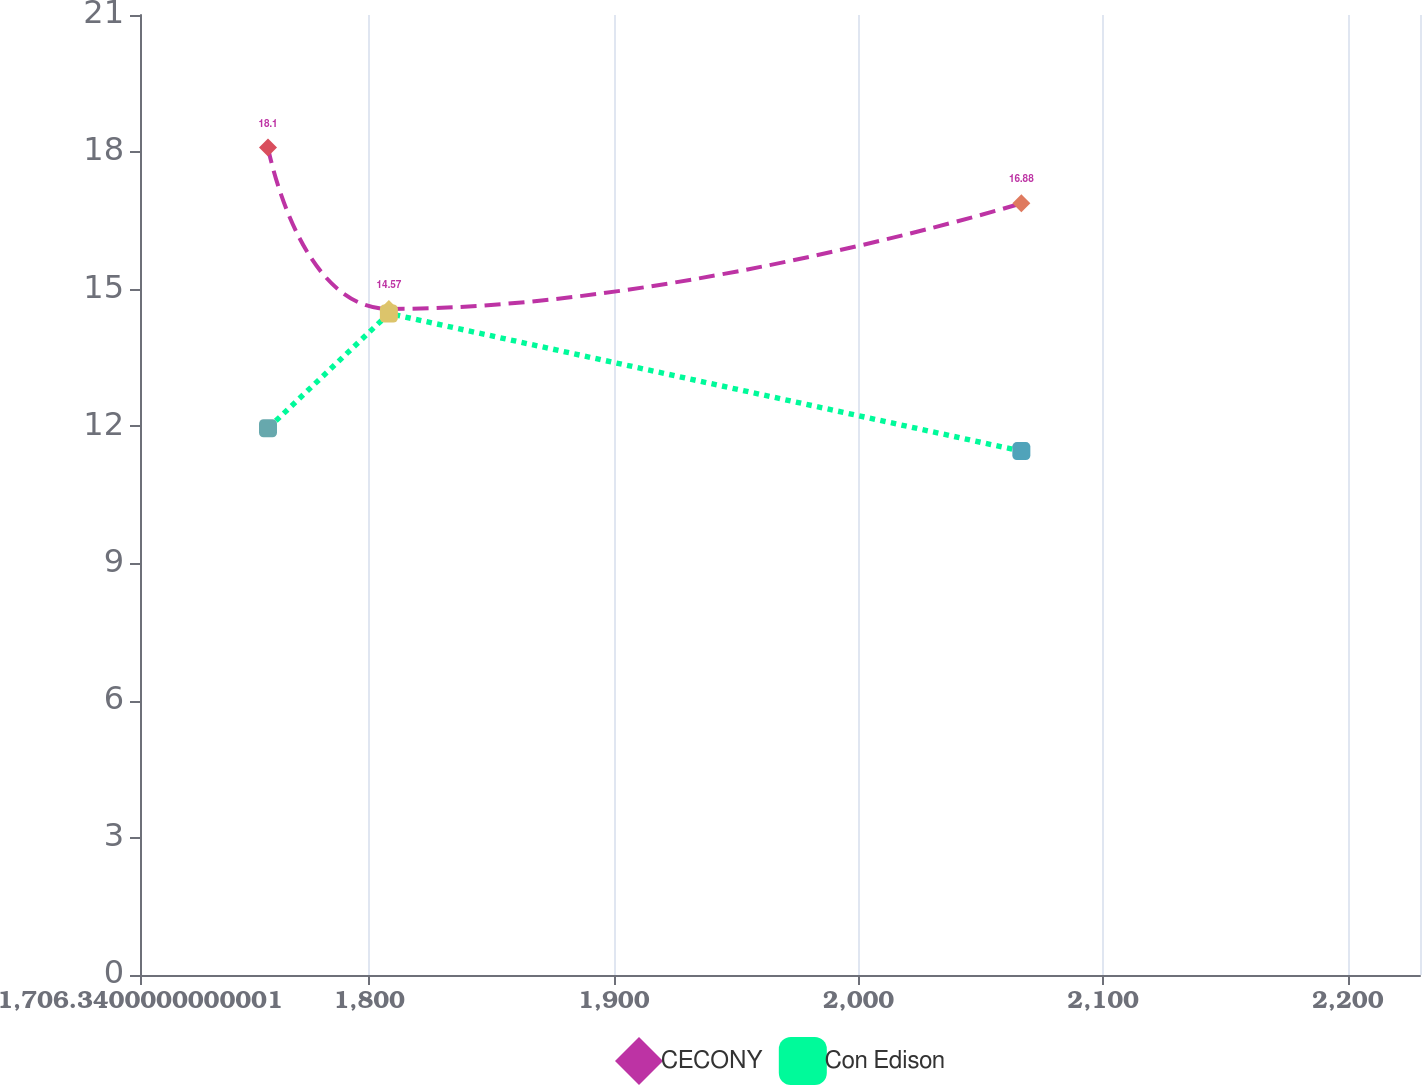Convert chart. <chart><loc_0><loc_0><loc_500><loc_500><line_chart><ecel><fcel>CECONY<fcel>Con Edison<nl><fcel>1758.66<fcel>18.1<fcel>11.96<nl><fcel>1808.07<fcel>14.57<fcel>14.47<nl><fcel>2066.59<fcel>16.88<fcel>11.46<nl><fcel>2232.45<fcel>14.14<fcel>13.81<nl><fcel>2281.86<fcel>16.48<fcel>14.18<nl></chart> 